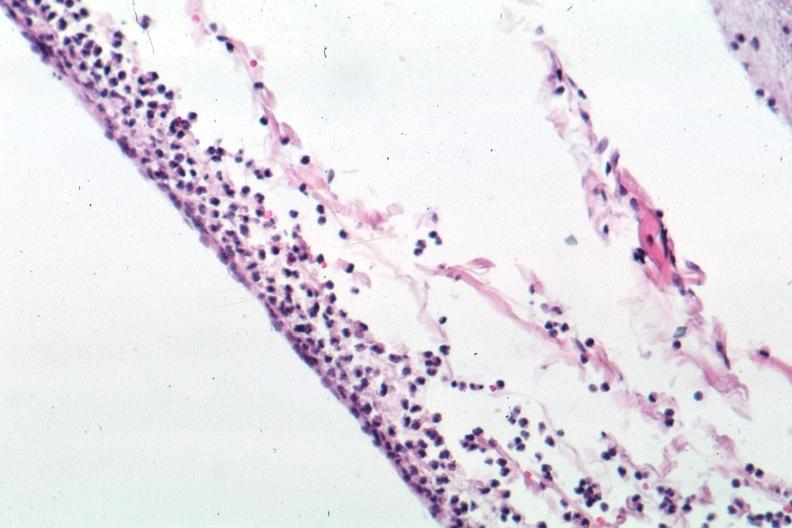does this image show well shown meningitis purulent?
Answer the question using a single word or phrase. Yes 